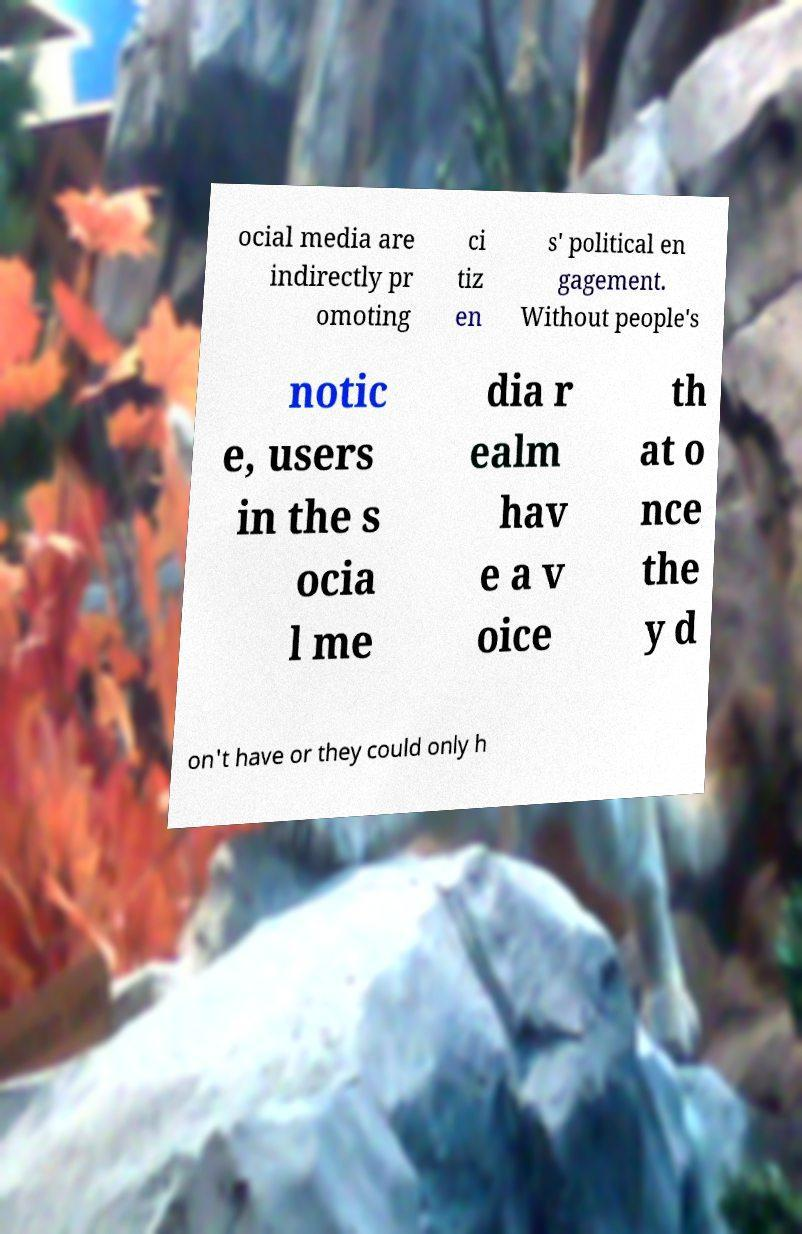I need the written content from this picture converted into text. Can you do that? ocial media are indirectly pr omoting ci tiz en s' political en gagement. Without people's notic e, users in the s ocia l me dia r ealm hav e a v oice th at o nce the y d on't have or they could only h 